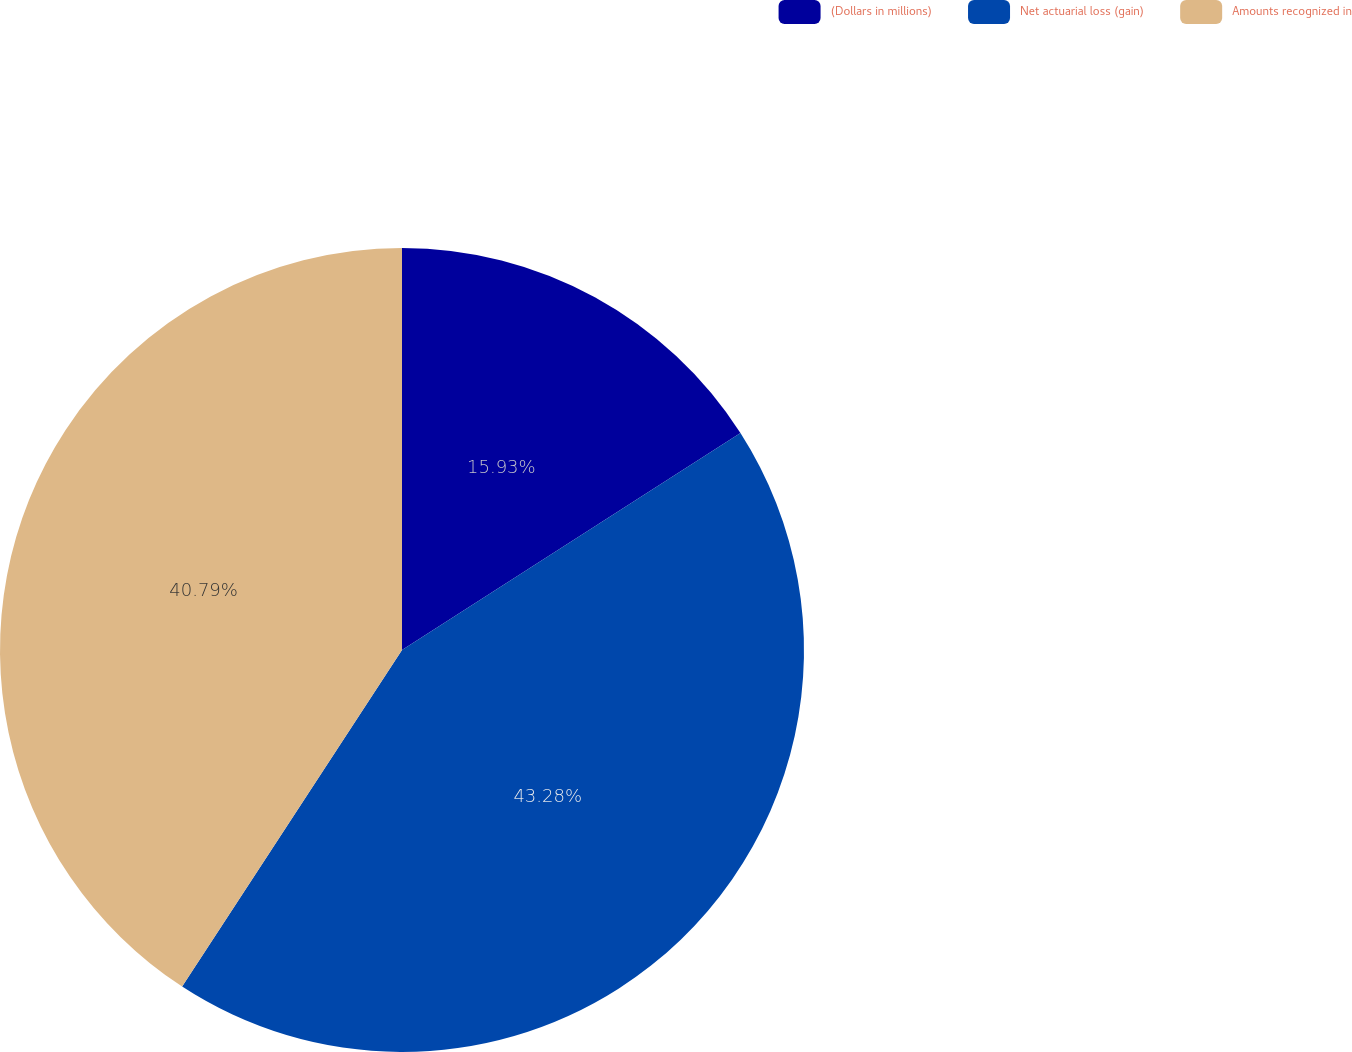<chart> <loc_0><loc_0><loc_500><loc_500><pie_chart><fcel>(Dollars in millions)<fcel>Net actuarial loss (gain)<fcel>Amounts recognized in<nl><fcel>15.93%<fcel>43.28%<fcel>40.79%<nl></chart> 